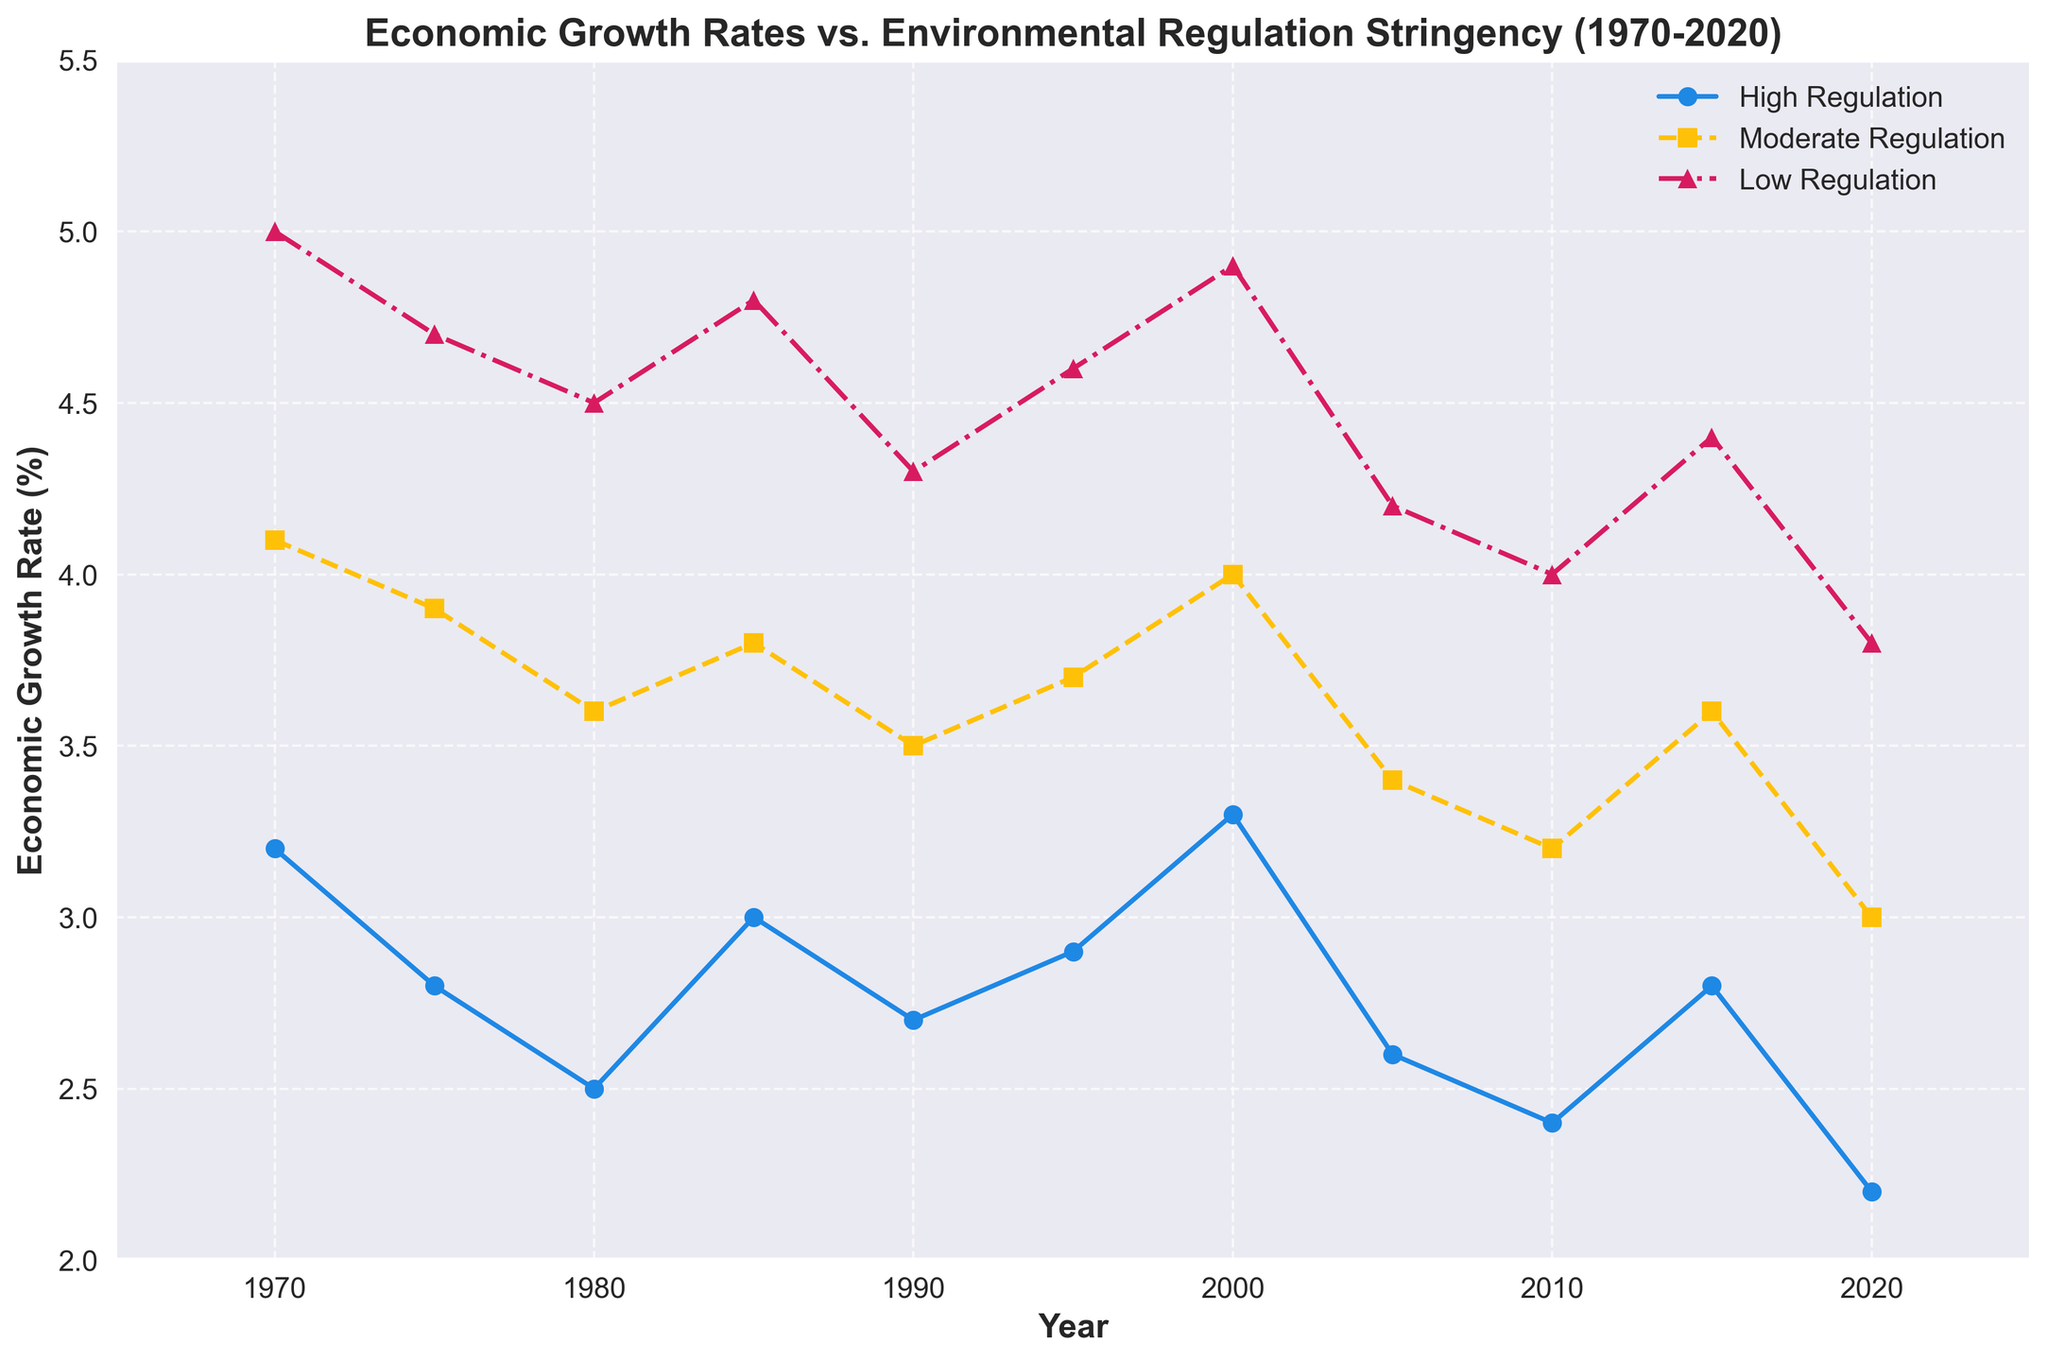What was the economic growth rate for nations with high environmental regulation in 1980? Locate the point for the year 1980 on the x-axis for the 'High Regulation' line (blue, marker 'o'). From the plot, the y value at this point is 2.5%.
Answer: 2.5% During which period did nations with moderate regulation experience the highest economic growth rate? Look for the highest point on the 'Moderate Regulation' line (yellow, marker 's'). The peak appears around the year 1970 with an economic growth rate of 4.1%.
Answer: 1970 Which type of regulation consistently had the highest economic growth rate from 1970 to 2020? Compare the three lines ('High Regulation', 'Moderate Regulation', 'Low Regulation'). The 'Low Regulation' line (red, marker '^') remains consistently higher than the other lines throughout the period.
Answer: Low Regulation What was the difference in economic growth rates between low and high regulation nations in 1985? Locate the points for the year 1985 for both 'High Regulation' and 'Low Regulation' lines. 'High Regulation' is 3.0%, and 'Low Regulation' is 4.8%. The difference is 4.8% - 3.0% = 1.8%.
Answer: 1.8% How did the economic growth rate for high regulation nations change from 2015 to 2020? Observe the 'High Regulation' line from 2015 (2.8%) to 2020 (2.2%). The economic growth rate decreased by 2.8% - 2.2% = 0.6%.
Answer: Decreased by 0.6% What is the average economic growth rate for moderate regulation nations between 1970 and 2020? Identify and add the 'Moderate Regulation' rates: 4.1 + 3.9 + 3.6 + 3.8 + 3.5 + 3.7 + 4.0 + 3.4 + 3.2 + 3.6 + 3.0 = 39.8. The average is 39.8 / 11 = 3.62%.
Answer: 3.62% Which year saw the smallest gap in economic growth rates between high and low regulation nations? Subtract 'High Regulation' from 'Low Regulation' for each year and identify the minimum value: (1975: 4.7 - 2.8 = 1.9), (1985: 4.8 - 3.0 = 1.8), (1990: 4.3 - 2.7 = 1.6, smallest gap).
Answer: 1990 For how many years did low regulation nations maintain an economic growth rate above 4.5%? Count the number of years on the 'Low Regulation' line where values are above 4.5%: 1970, 1975, 1980, 1985, 1995, 2000, 2005, and 2015.
Answer: 8 years Did any regulation type experience a growth rate decrease in every period (5-year interval)? Analyze all intervals: 'High Regulation' shows decreases in most intervals but not consistently in every interval (e.g., slight increase from 1980 to 1985). No regulation type decreases every interval.
Answer: No 